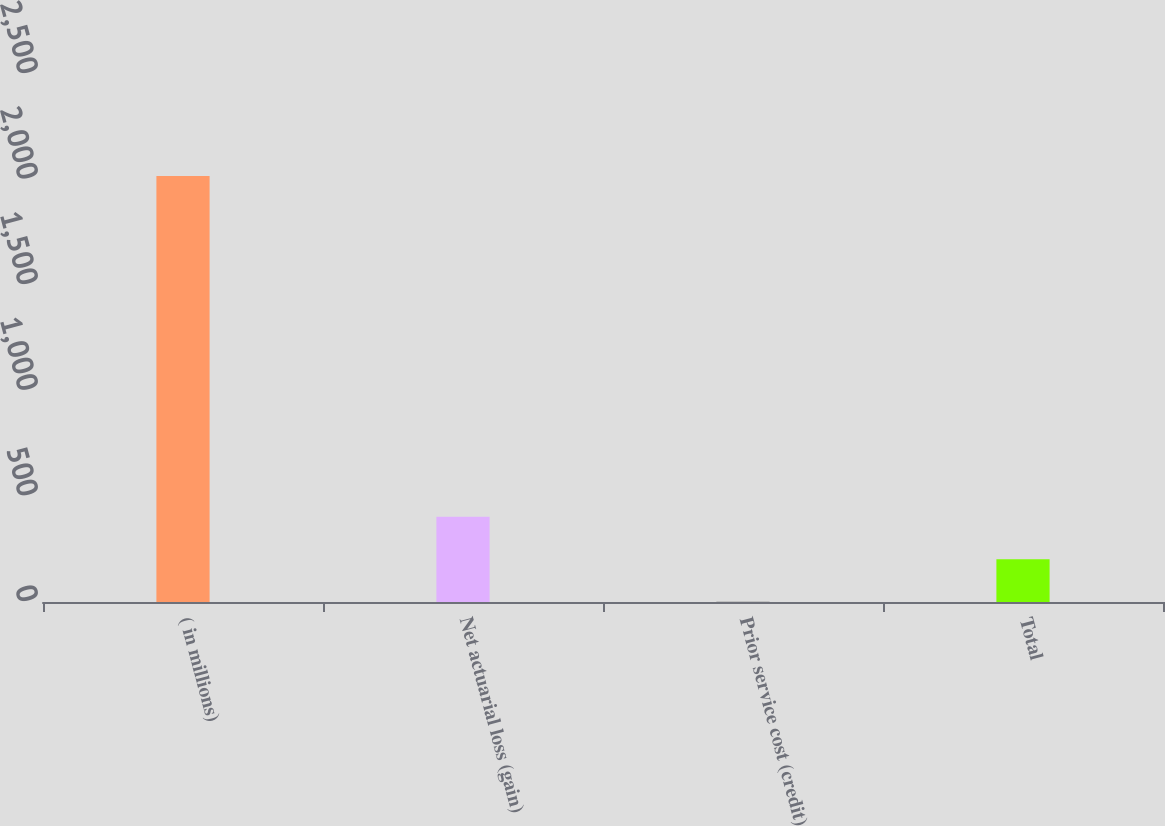<chart> <loc_0><loc_0><loc_500><loc_500><bar_chart><fcel>( in millions)<fcel>Net actuarial loss (gain)<fcel>Prior service cost (credit)<fcel>Total<nl><fcel>2017<fcel>404.04<fcel>0.8<fcel>202.42<nl></chart> 